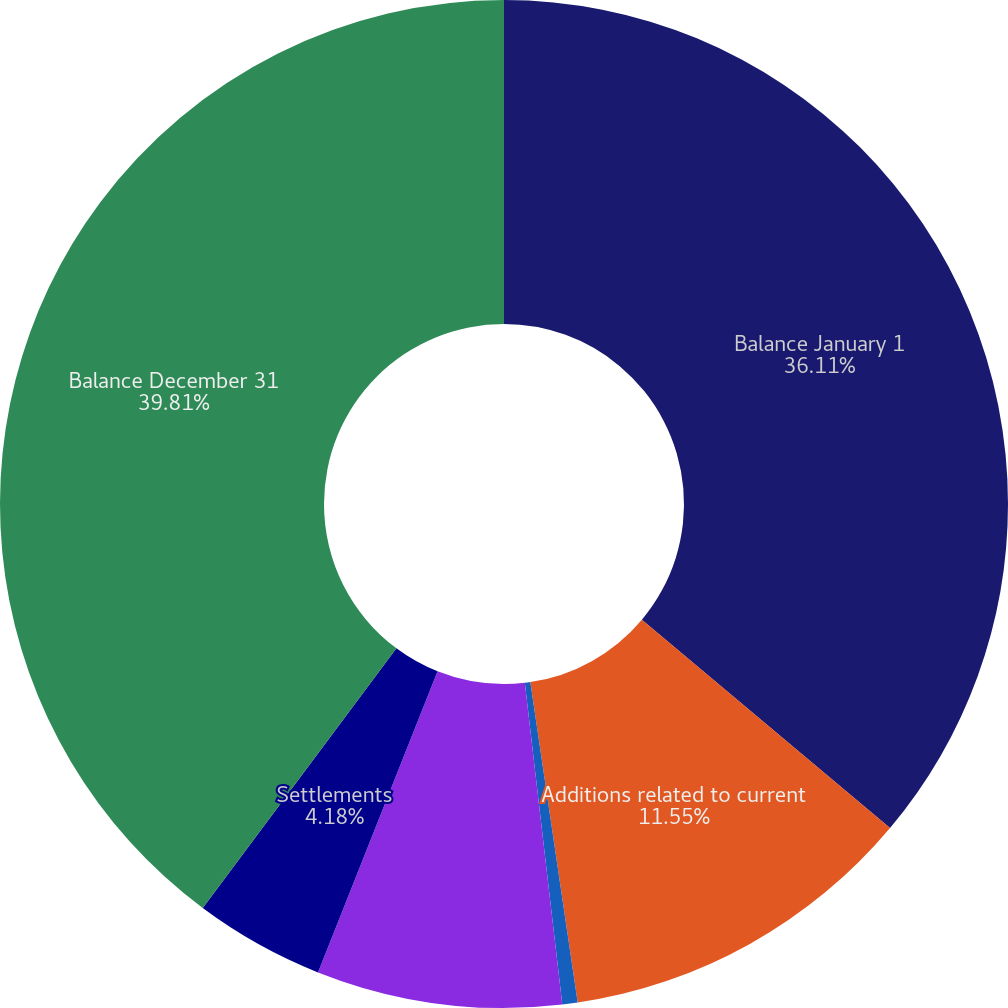Convert chart. <chart><loc_0><loc_0><loc_500><loc_500><pie_chart><fcel>Balance January 1<fcel>Additions related to current<fcel>Additions related to prior<fcel>Reductions for tax positions<fcel>Settlements<fcel>Balance December 31<nl><fcel>36.11%<fcel>11.55%<fcel>0.49%<fcel>7.86%<fcel>4.18%<fcel>39.8%<nl></chart> 